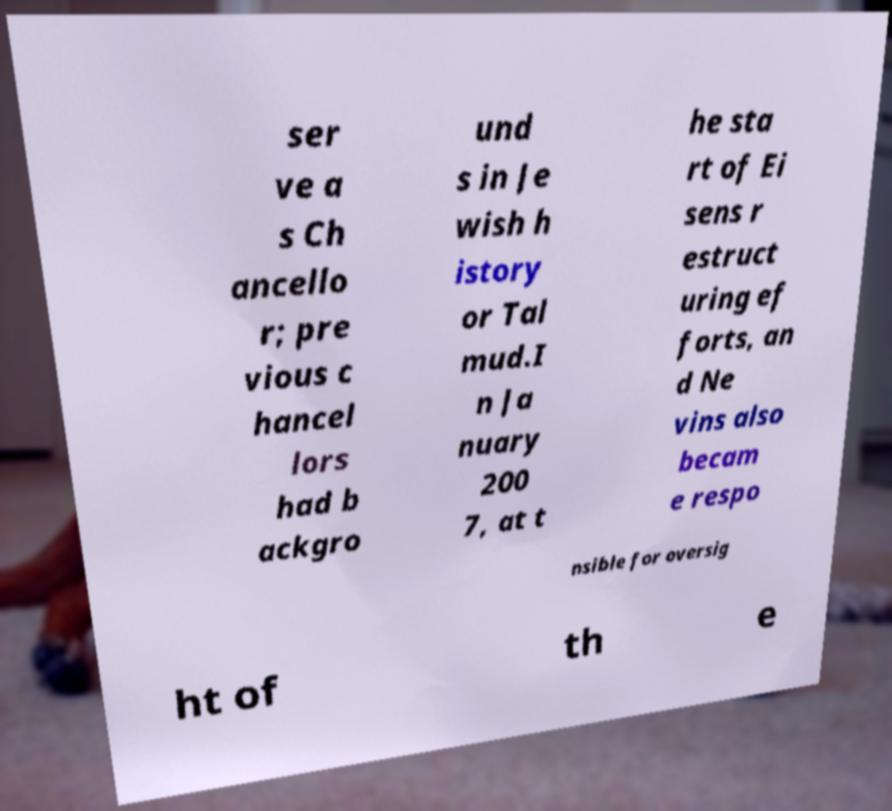Could you extract and type out the text from this image? ser ve a s Ch ancello r; pre vious c hancel lors had b ackgro und s in Je wish h istory or Tal mud.I n Ja nuary 200 7, at t he sta rt of Ei sens r estruct uring ef forts, an d Ne vins also becam e respo nsible for oversig ht of th e 